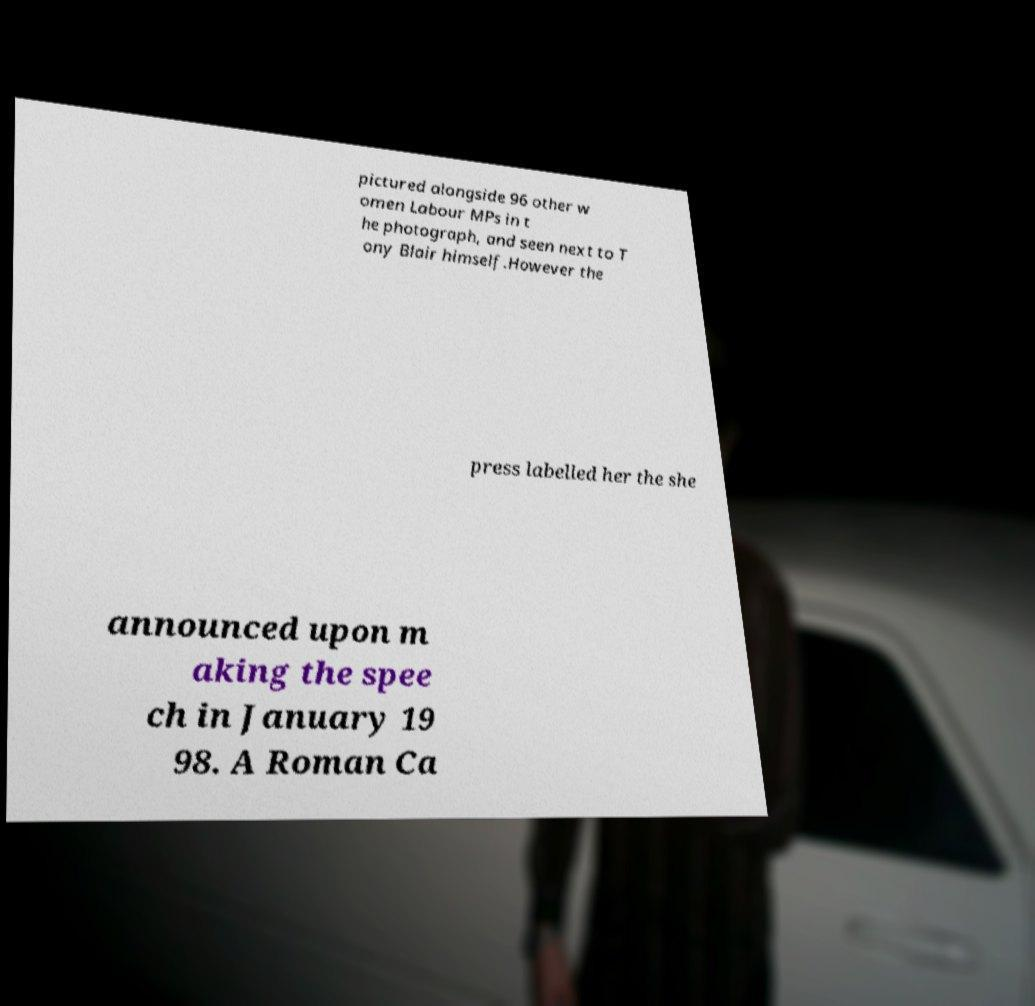Can you read and provide the text displayed in the image?This photo seems to have some interesting text. Can you extract and type it out for me? pictured alongside 96 other w omen Labour MPs in t he photograph, and seen next to T ony Blair himself.However the press labelled her the she announced upon m aking the spee ch in January 19 98. A Roman Ca 